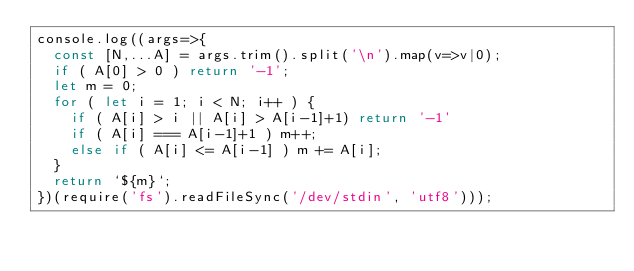Convert code to text. <code><loc_0><loc_0><loc_500><loc_500><_JavaScript_>console.log((args=>{
  const [N,...A] = args.trim().split('\n').map(v=>v|0);
  if ( A[0] > 0 ) return '-1';
  let m = 0;
  for ( let i = 1; i < N; i++ ) {
    if ( A[i] > i || A[i] > A[i-1]+1) return '-1'
    if ( A[i] === A[i-1]+1 ) m++;
    else if ( A[i] <= A[i-1] ) m += A[i];
  }
  return `${m}`;
})(require('fs').readFileSync('/dev/stdin', 'utf8')));
</code> 